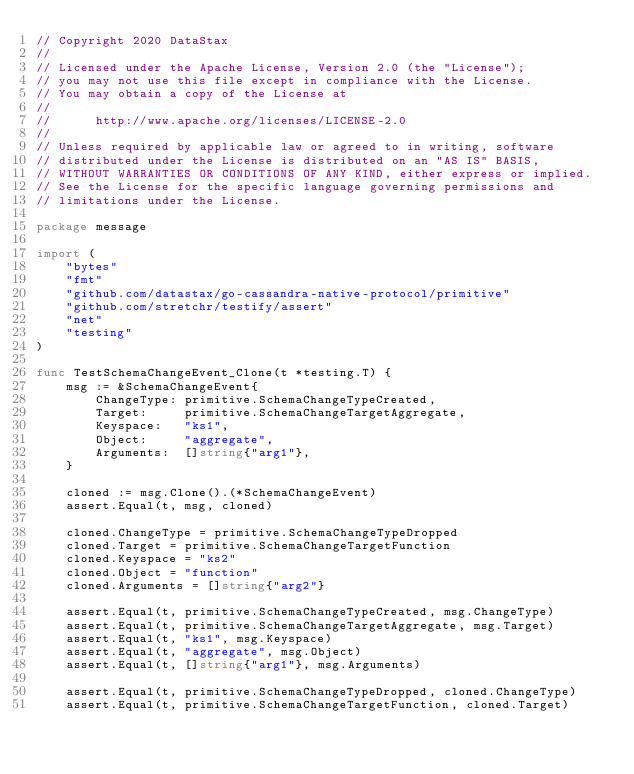<code> <loc_0><loc_0><loc_500><loc_500><_Go_>// Copyright 2020 DataStax
//
// Licensed under the Apache License, Version 2.0 (the "License");
// you may not use this file except in compliance with the License.
// You may obtain a copy of the License at
//
//      http://www.apache.org/licenses/LICENSE-2.0
//
// Unless required by applicable law or agreed to in writing, software
// distributed under the License is distributed on an "AS IS" BASIS,
// WITHOUT WARRANTIES OR CONDITIONS OF ANY KIND, either express or implied.
// See the License for the specific language governing permissions and
// limitations under the License.

package message

import (
	"bytes"
	"fmt"
	"github.com/datastax/go-cassandra-native-protocol/primitive"
	"github.com/stretchr/testify/assert"
	"net"
	"testing"
)

func TestSchemaChangeEvent_Clone(t *testing.T) {
	msg := &SchemaChangeEvent{
		ChangeType: primitive.SchemaChangeTypeCreated,
		Target:     primitive.SchemaChangeTargetAggregate,
		Keyspace:   "ks1",
		Object:     "aggregate",
		Arguments:  []string{"arg1"},
	}

	cloned := msg.Clone().(*SchemaChangeEvent)
	assert.Equal(t, msg, cloned)

	cloned.ChangeType = primitive.SchemaChangeTypeDropped
	cloned.Target = primitive.SchemaChangeTargetFunction
	cloned.Keyspace = "ks2"
	cloned.Object = "function"
	cloned.Arguments = []string{"arg2"}

	assert.Equal(t, primitive.SchemaChangeTypeCreated, msg.ChangeType)
	assert.Equal(t, primitive.SchemaChangeTargetAggregate, msg.Target)
	assert.Equal(t, "ks1", msg.Keyspace)
	assert.Equal(t, "aggregate", msg.Object)
	assert.Equal(t, []string{"arg1"}, msg.Arguments)

	assert.Equal(t, primitive.SchemaChangeTypeDropped, cloned.ChangeType)
	assert.Equal(t, primitive.SchemaChangeTargetFunction, cloned.Target)</code> 